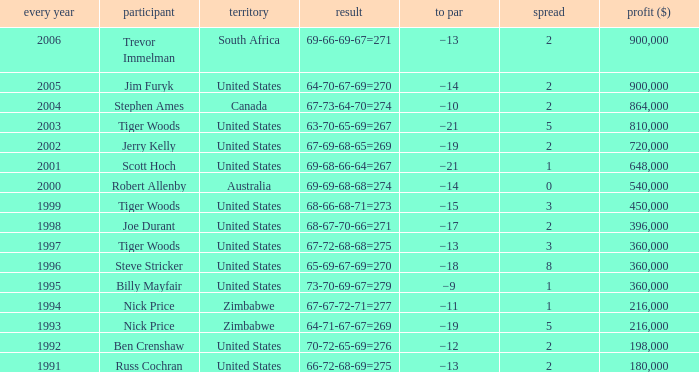Which Margin has a Country of united states, and a Score of 63-70-65-69=267? 5.0. 